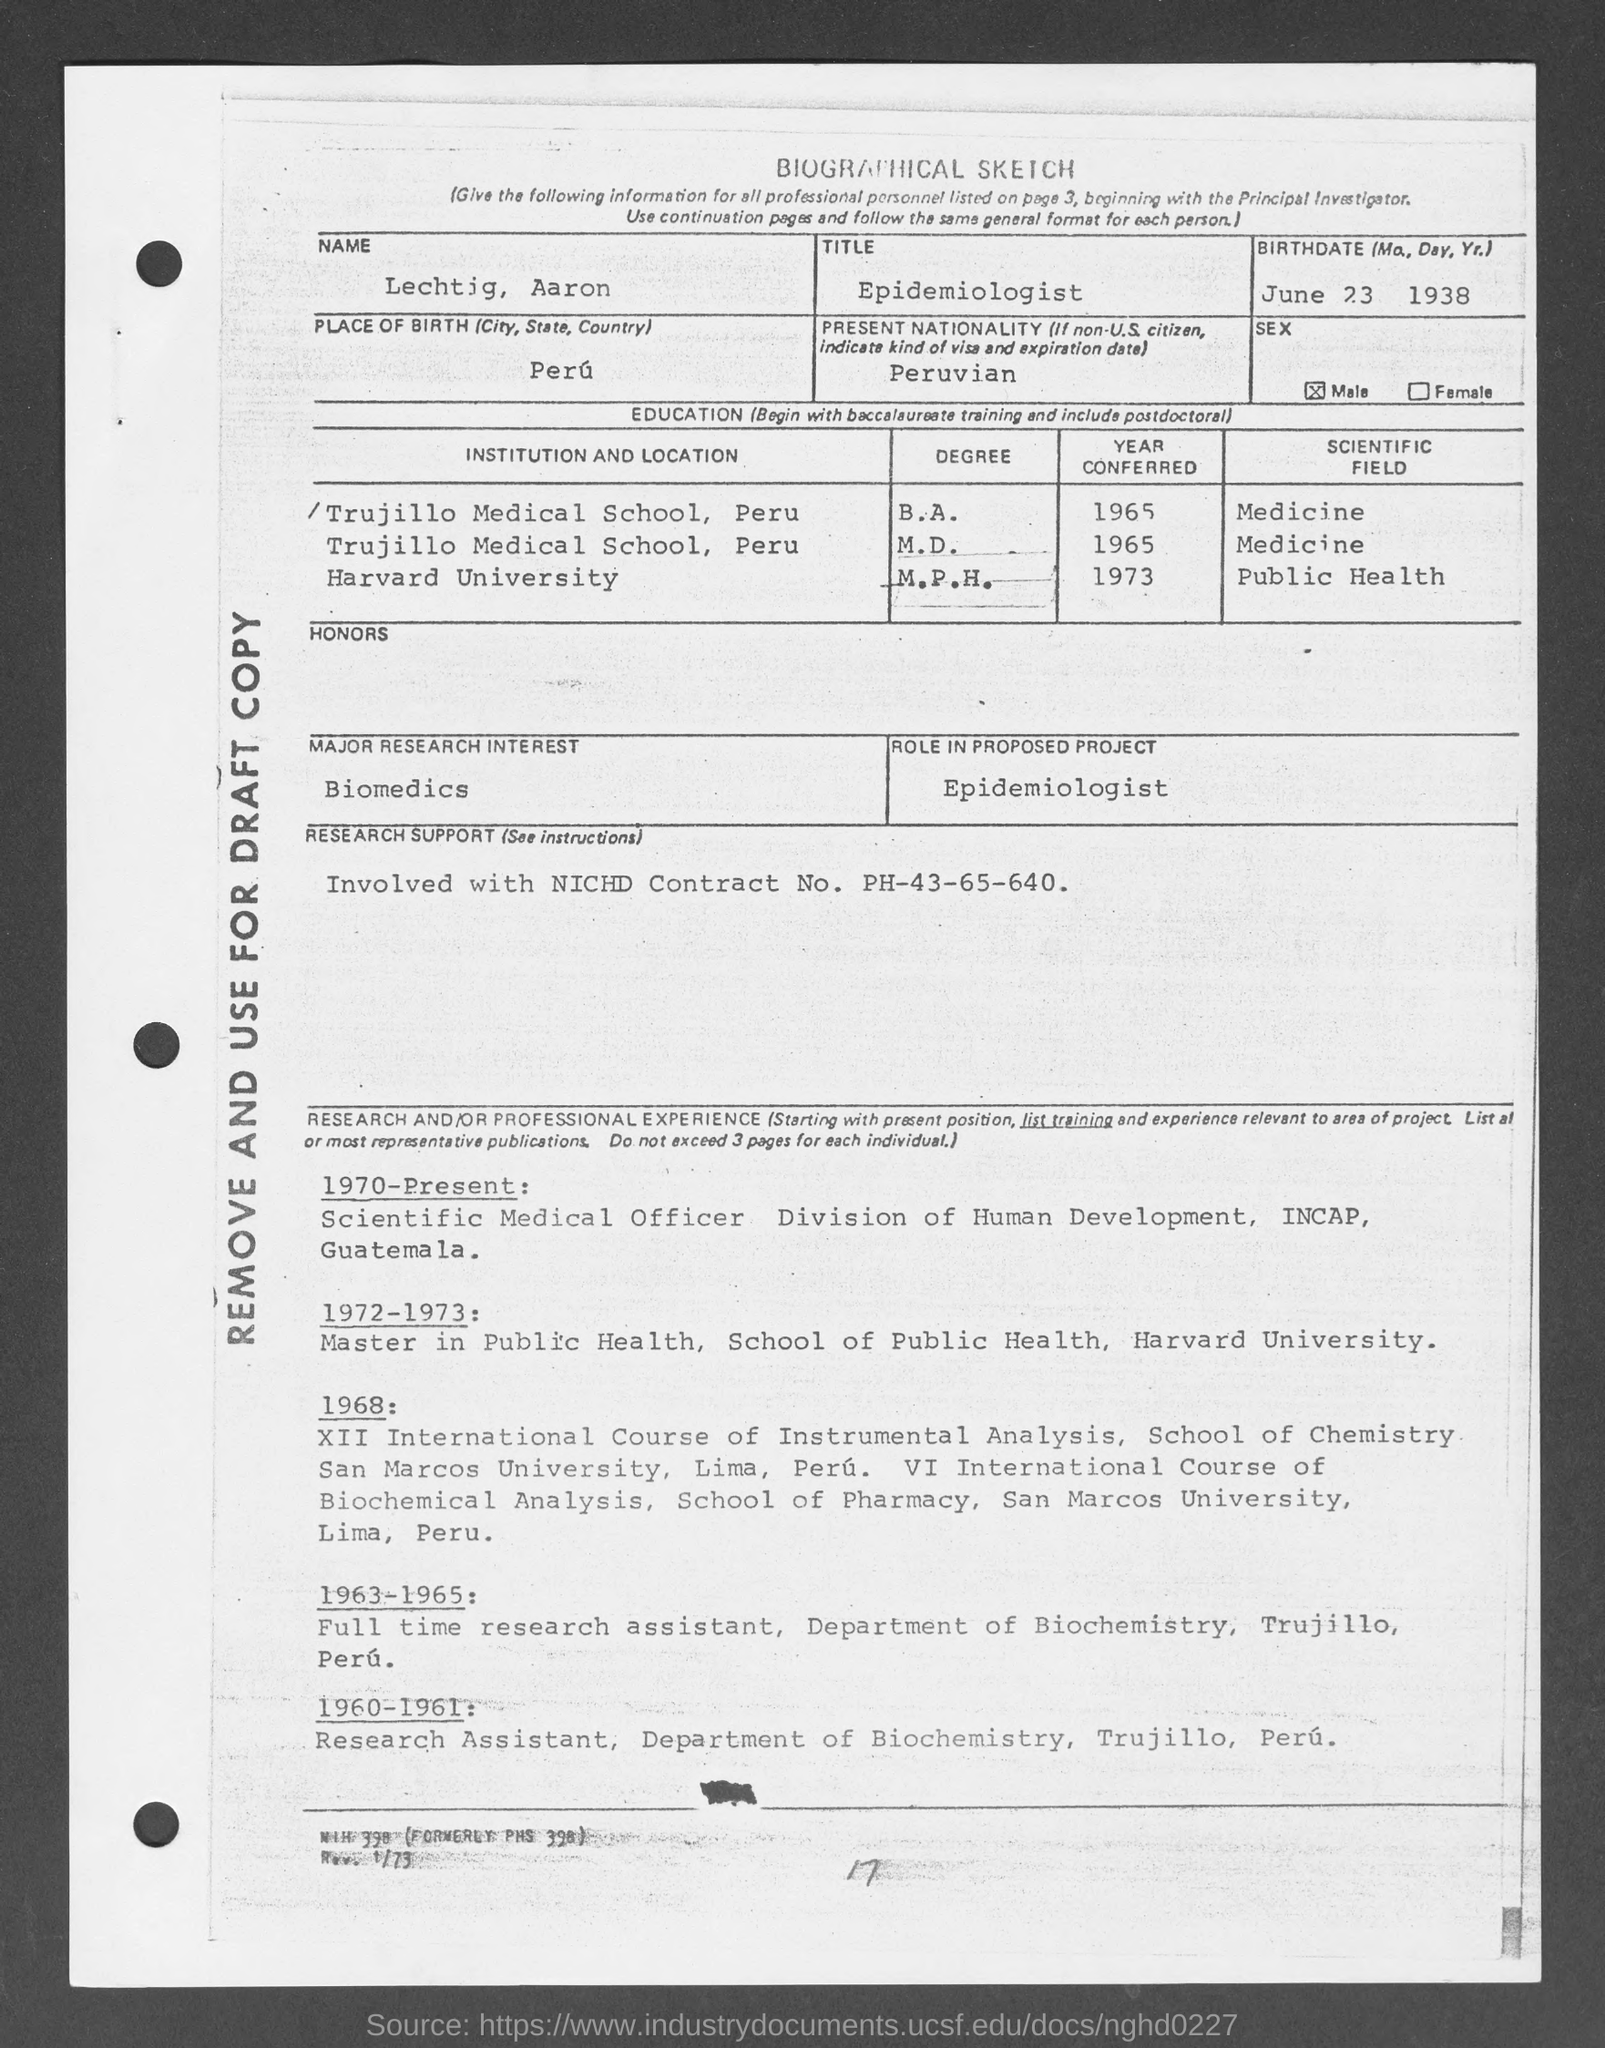Mention a couple of crucial points in this snapshot. The present nationality mentioned in the given sketch is PERUVIAN. In the year 1965, the person in question completed his Bachelor of Arts degree in the field of Medicine. The name mentioned in the given biological sketch is LECHTIG AARON. The title mentioned in the given sketch is 'Epidemiologist.' The major research interest mentioned in the given sketch is Biomedics. 